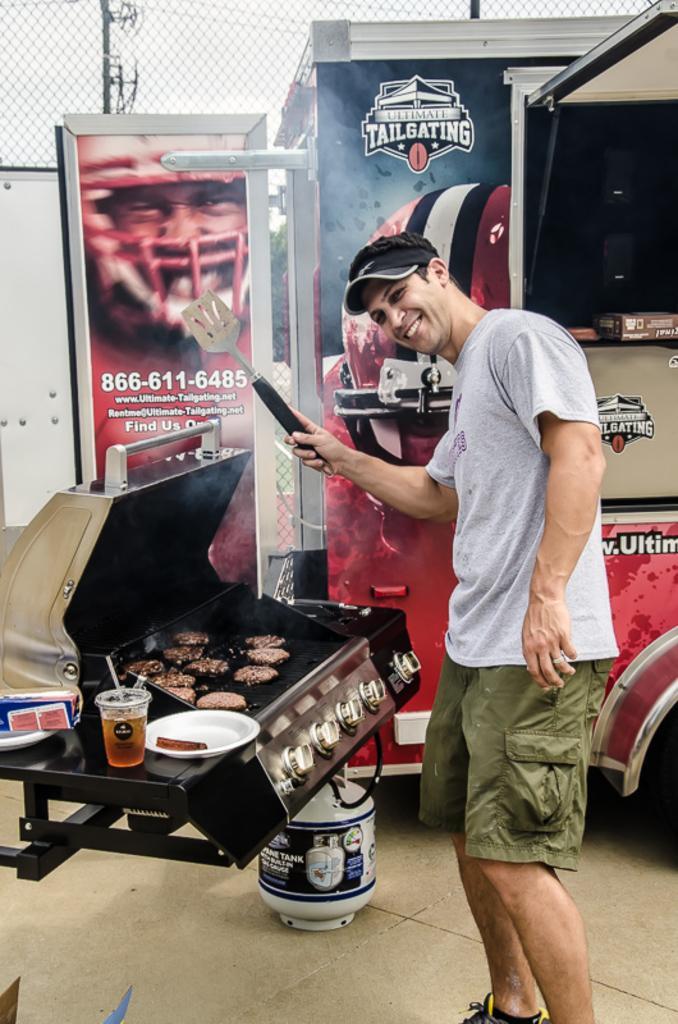Please provide a concise description of this image. In the foreground of this image, there is a man standing and holding a spatula. In front of him, there is a outdoor burner gas grill on which some food is cooking. Beside, there is a glass, platters and on the ground, there is a cylinder. In the background, there is a vehicle, poster and the fencing. 